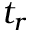Convert formula to latex. <formula><loc_0><loc_0><loc_500><loc_500>t _ { r }</formula> 